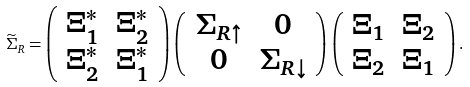Convert formula to latex. <formula><loc_0><loc_0><loc_500><loc_500>\widetilde { \Sigma } _ { R } = \left ( \begin{array} { c c } \Xi _ { 1 } ^ { * } & \Xi _ { 2 } ^ { * } \\ \Xi _ { 2 } ^ { * } & \Xi _ { 1 } ^ { * } \end{array} \right ) \left ( \begin{array} { c c } \Sigma _ { R \uparrow } & 0 \\ 0 & \Sigma _ { R \downarrow } \end{array} \right ) \left ( \begin{array} { c c } \Xi _ { 1 } & \Xi _ { 2 } \\ \Xi _ { 2 } & \Xi _ { 1 } \end{array} \right ) .</formula> 